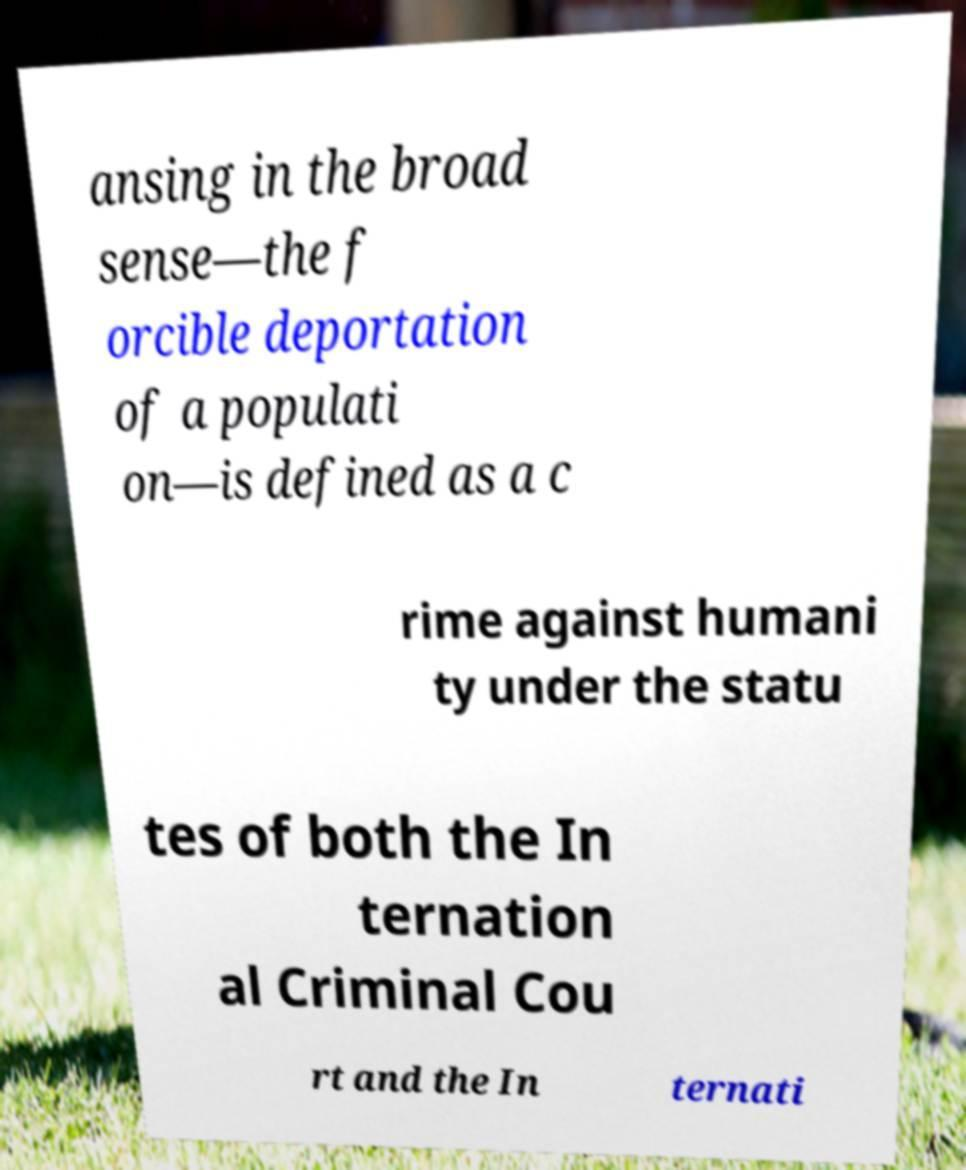Please read and relay the text visible in this image. What does it say? ansing in the broad sense—the f orcible deportation of a populati on—is defined as a c rime against humani ty under the statu tes of both the In ternation al Criminal Cou rt and the In ternati 